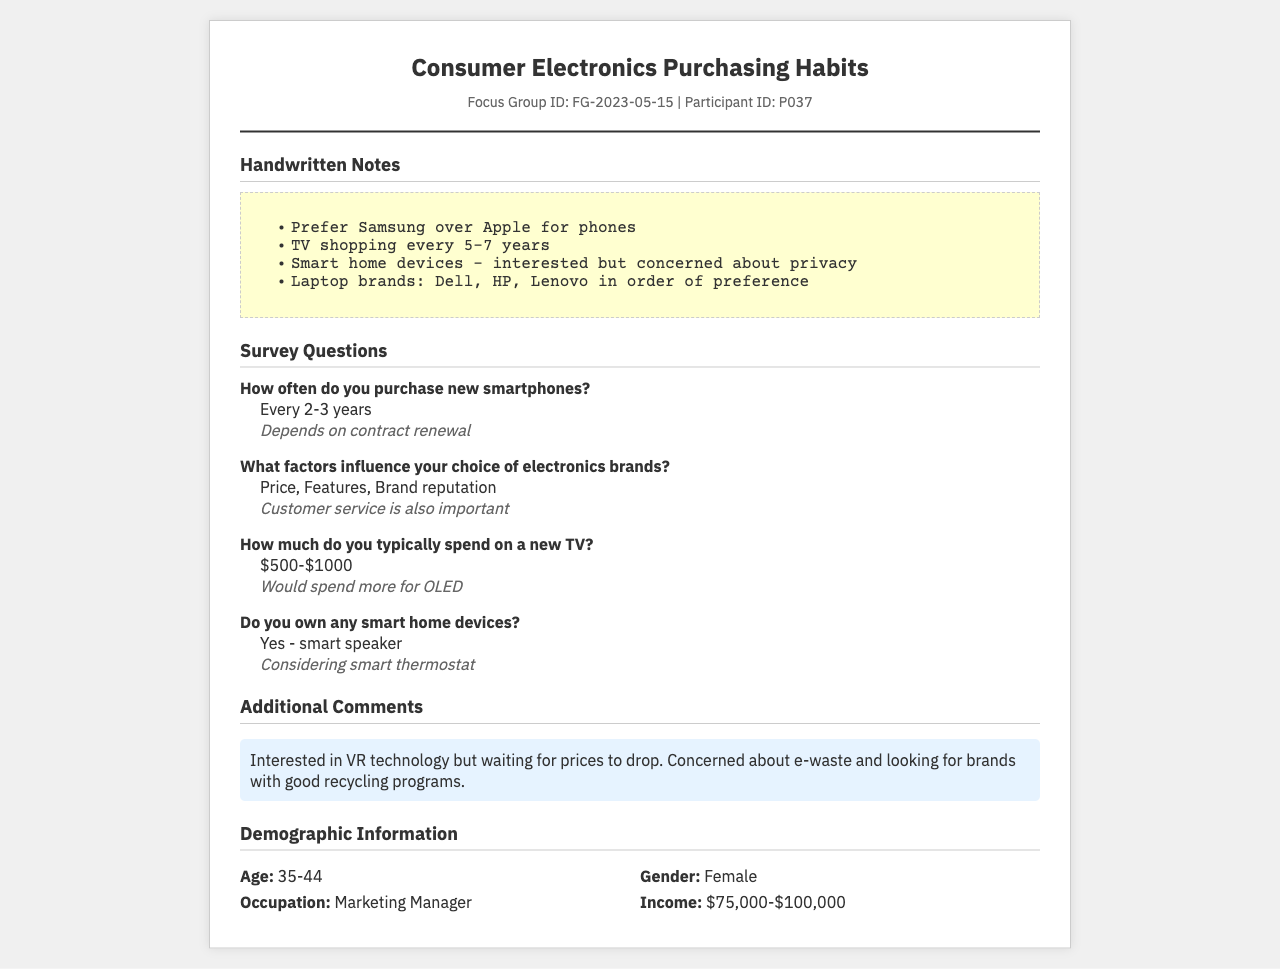What is the participant's preference for smartphone brands? The participant prefers Samsung over Apple for phones, as noted in the handwritten section.
Answer: Samsung How often does the participant purchase new smartphones? The survey states that the participant purchases new smartphones every 2-3 years.
Answer: Every 2-3 years What is the price range the participant typically spends on a new TV? The answer to this survey question indicates that the participant usually spends between $500 and $1000 on a new TV.
Answer: $500-$1000 What brand of smart home device does the participant currently own? The document mentions that the participant owns a smart speaker as a smart home device.
Answer: Smart speaker What is the participant's age range? The demographic information section specifies that the participant falls within the age range of 35-44.
Answer: 35-44 How concerned is the participant about privacy regarding smart home devices? The handwritten notes indicate that the participant is interested in smart home devices but has concerns about privacy.
Answer: Concerned What is the participant's occupation? The demographic section lists the participant's occupation as a Marketing Manager.
Answer: Marketing Manager What additional technology is the participant interested in? The additional comments reveal that the participant is interested in VR technology.
Answer: VR technology What income bracket does the participant fall into? The demographic information states that the participant's income is between $75,000 and $100,000.
Answer: $75,000-$100,000 